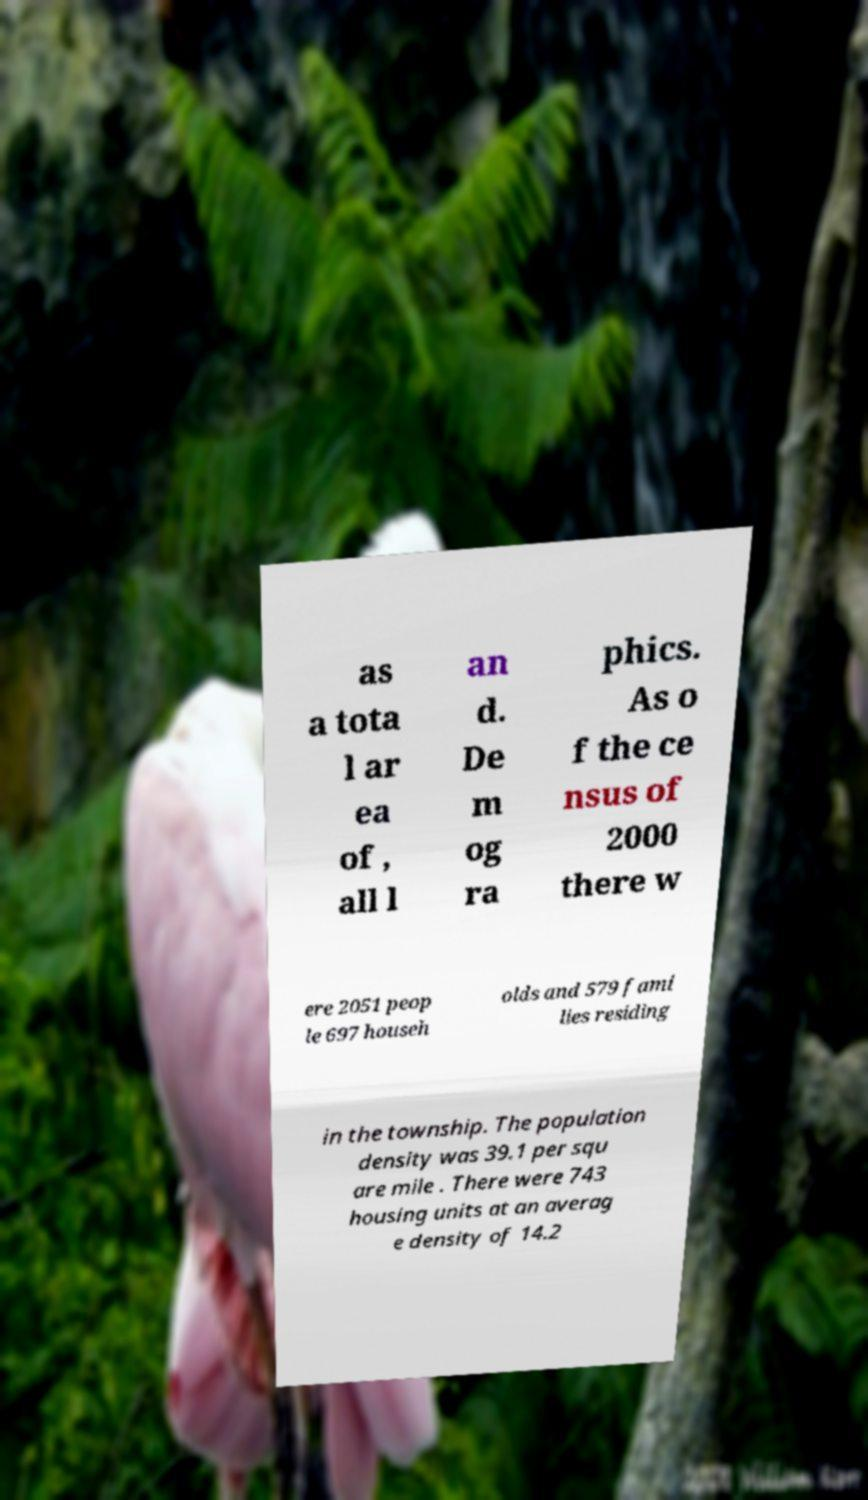Please read and relay the text visible in this image. What does it say? as a tota l ar ea of , all l an d. De m og ra phics. As o f the ce nsus of 2000 there w ere 2051 peop le 697 househ olds and 579 fami lies residing in the township. The population density was 39.1 per squ are mile . There were 743 housing units at an averag e density of 14.2 